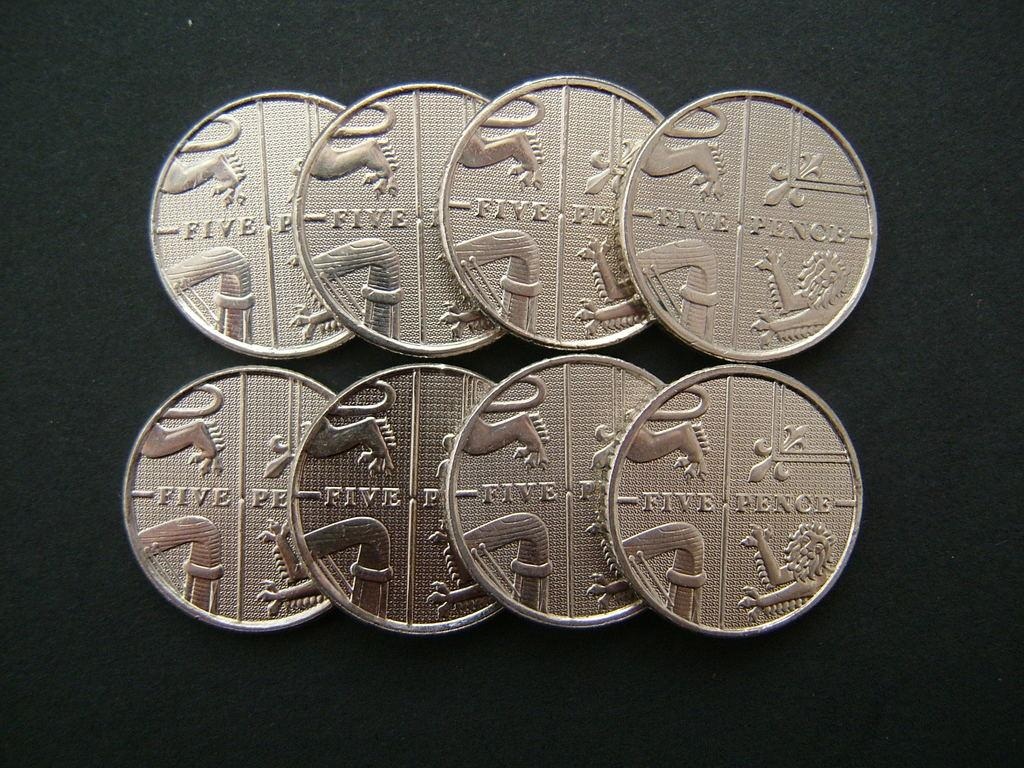Provide a one-sentence caption for the provided image. Eight five pence coins spread out on a dark surface. 